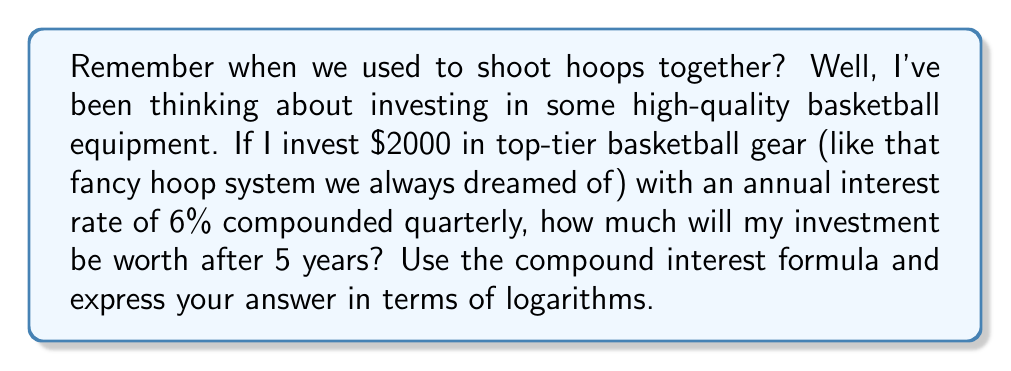Help me with this question. Let's approach this step-by-step using the compound interest formula:

1) The compound interest formula is:
   $A = P(1 + \frac{r}{n})^{nt}$

   Where:
   $A$ = final amount
   $P$ = principal (initial investment)
   $r$ = annual interest rate (as a decimal)
   $n$ = number of times interest is compounded per year
   $t$ = number of years

2) Given information:
   $P = 2000$
   $r = 0.06$ (6% expressed as a decimal)
   $n = 4$ (compounded quarterly means 4 times per year)
   $t = 5$ years

3) Substituting these values into the formula:
   $A = 2000(1 + \frac{0.06}{4})^{4(5)}$

4) Simplify inside the parentheses:
   $A = 2000(1.015)^{20}$

5) To solve this using logarithms, we can take the natural log of both sides:
   $\ln(A) = \ln(2000) + 20\ln(1.015)$

6) Calculate:
   $\ln(A) = 7.6009 + 20(0.0149) = 7.6009 + 0.2980 = 7.8989$

7) To get A, we need to apply the exponential function:
   $A = e^{7.8989} = 2682.5796$

Therefore, the investment will be worth approximately $2682.58 after 5 years.
Answer: $A = e^{7.8989} \approx 2682.58$ 